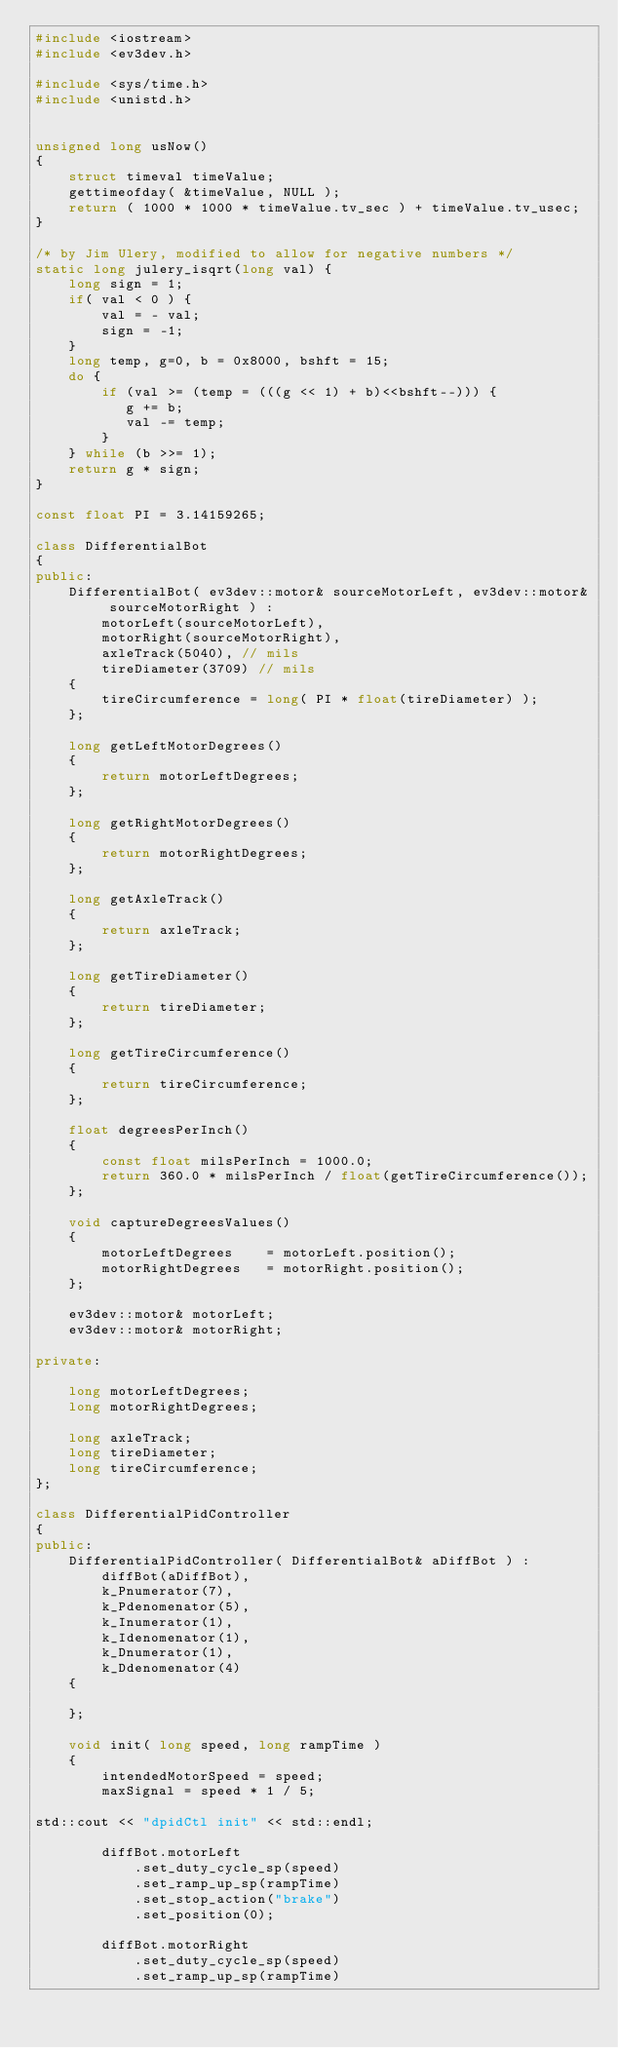<code> <loc_0><loc_0><loc_500><loc_500><_C++_>#include <iostream>
#include <ev3dev.h>

#include <sys/time.h>
#include <unistd.h>


unsigned long usNow()
{
    struct timeval timeValue;
    gettimeofday( &timeValue, NULL );
    return ( 1000 * 1000 * timeValue.tv_sec ) + timeValue.tv_usec;
}

/* by Jim Ulery, modified to allow for negative numbers */
static long julery_isqrt(long val) {
    long sign = 1;
    if( val < 0 ) {
        val = - val;
        sign = -1;
    }
    long temp, g=0, b = 0x8000, bshft = 15;
    do {
        if (val >= (temp = (((g << 1) + b)<<bshft--))) {
           g += b;
           val -= temp;
        }
    } while (b >>= 1);
    return g * sign;
}

const float PI = 3.14159265;

class DifferentialBot
{
public:
    DifferentialBot( ev3dev::motor& sourceMotorLeft, ev3dev::motor& sourceMotorRight ) :
        motorLeft(sourceMotorLeft),
        motorRight(sourceMotorRight),
        axleTrack(5040), // mils
        tireDiameter(3709) // mils
    {
        tireCircumference = long( PI * float(tireDiameter) );
    };

    long getLeftMotorDegrees()
    {
        return motorLeftDegrees;
    };

    long getRightMotorDegrees()
    {
        return motorRightDegrees;
    };

    long getAxleTrack()
    {
        return axleTrack;
    };

    long getTireDiameter()
    {
        return tireDiameter;
    };

    long getTireCircumference()
    {
        return tireCircumference;
    };

    float degreesPerInch()
    {
        const float milsPerInch = 1000.0;
        return 360.0 * milsPerInch / float(getTireCircumference());
    };

    void captureDegreesValues()
    {
        motorLeftDegrees    = motorLeft.position();
        motorRightDegrees   = motorRight.position();
    };

    ev3dev::motor& motorLeft;
    ev3dev::motor& motorRight;

private:

    long motorLeftDegrees;
    long motorRightDegrees;

    long axleTrack;
    long tireDiameter;
    long tireCircumference;
};

class DifferentialPidController
{
public:
    DifferentialPidController( DifferentialBot& aDiffBot ) :
        diffBot(aDiffBot),
        k_Pnumerator(7),
        k_Pdenomenator(5),
        k_Inumerator(1),
        k_Idenomenator(1),
        k_Dnumerator(1),
        k_Ddenomenator(4)
    {

    };

    void init( long speed, long rampTime )
    {
        intendedMotorSpeed = speed;
        maxSignal = speed * 1 / 5;

std::cout << "dpidCtl init" << std::endl;

        diffBot.motorLeft
            .set_duty_cycle_sp(speed)
            .set_ramp_up_sp(rampTime)
            .set_stop_action("brake")
            .set_position(0);

        diffBot.motorRight
            .set_duty_cycle_sp(speed)
            .set_ramp_up_sp(rampTime)</code> 